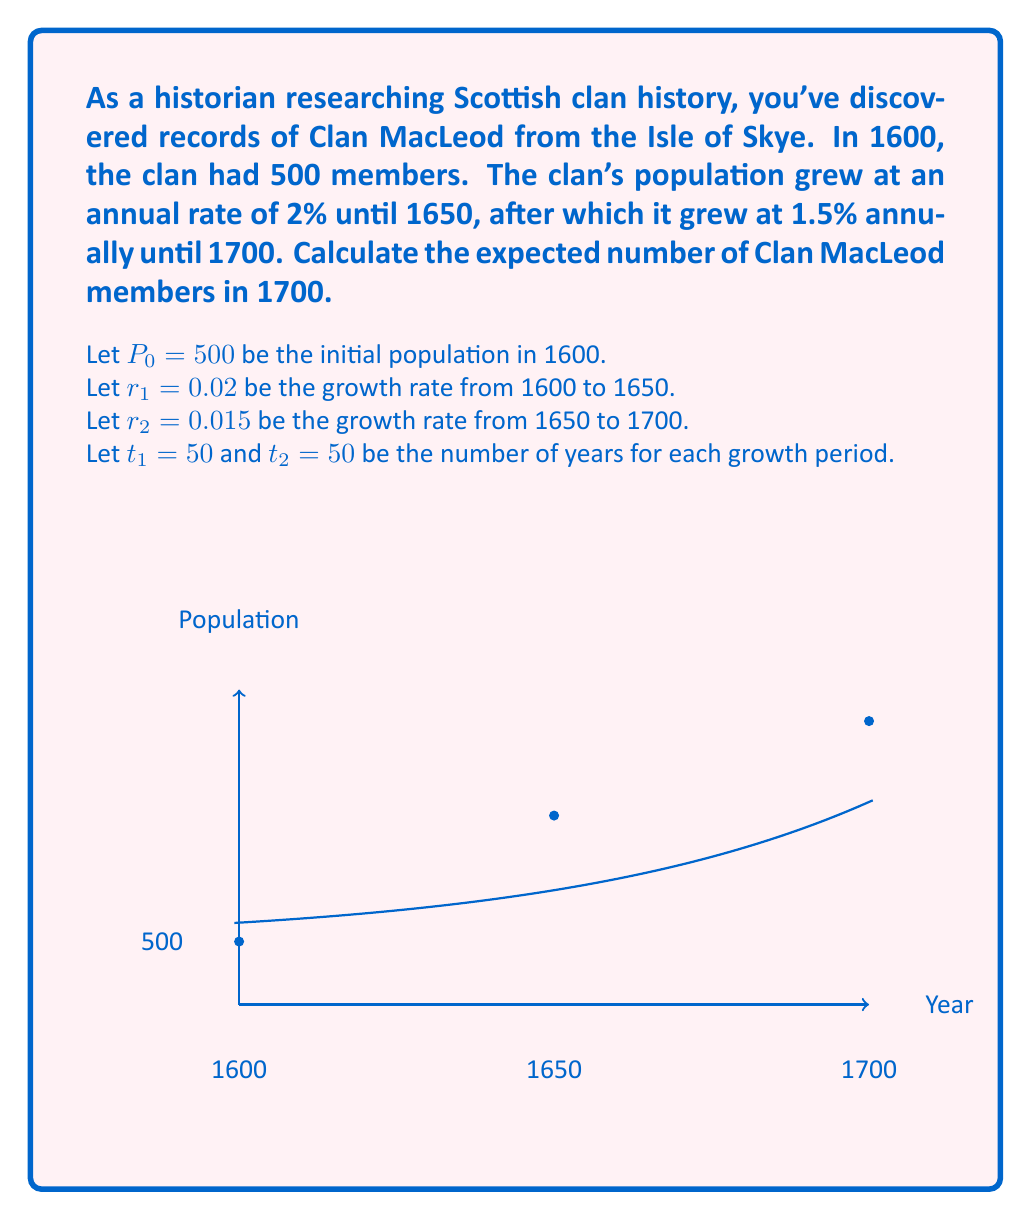Show me your answer to this math problem. To solve this problem, we'll use the compound interest formula for population growth:

$$P_t = P_0(1 + r)^t$$

where $P_t$ is the population after time $t$, $P_0$ is the initial population, $r$ is the growth rate, and $t$ is the time period.

Step 1: Calculate the population in 1650 (after the first 50 years)
$$P_{1650} = 500(1 + 0.02)^{50} = 500 \times 2.6916 = 1345.8$$

Step 2: Use the population in 1650 as the new initial population for the next 50 years
$$P_{1700} = 1345.8(1 + 0.015)^{50} = 1345.8 \times 2.1071 = 2835.7$$

Step 3: Round to the nearest whole number, as we can't have fractional clan members.

Therefore, the expected number of Clan MacLeod members in 1700 is approximately 2,836.
Answer: 2,836 members 